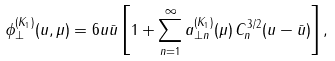Convert formula to latex. <formula><loc_0><loc_0><loc_500><loc_500>\phi _ { \perp } ^ { ( K _ { 1 } ) } ( u , \mu ) = 6 u \bar { u } \left [ 1 + \sum _ { n = 1 } ^ { \infty } a _ { \perp n } ^ { ( K _ { 1 } ) } ( \mu ) \, C _ { n } ^ { 3 / 2 } ( u - \bar { u } ) \right ] ,</formula> 